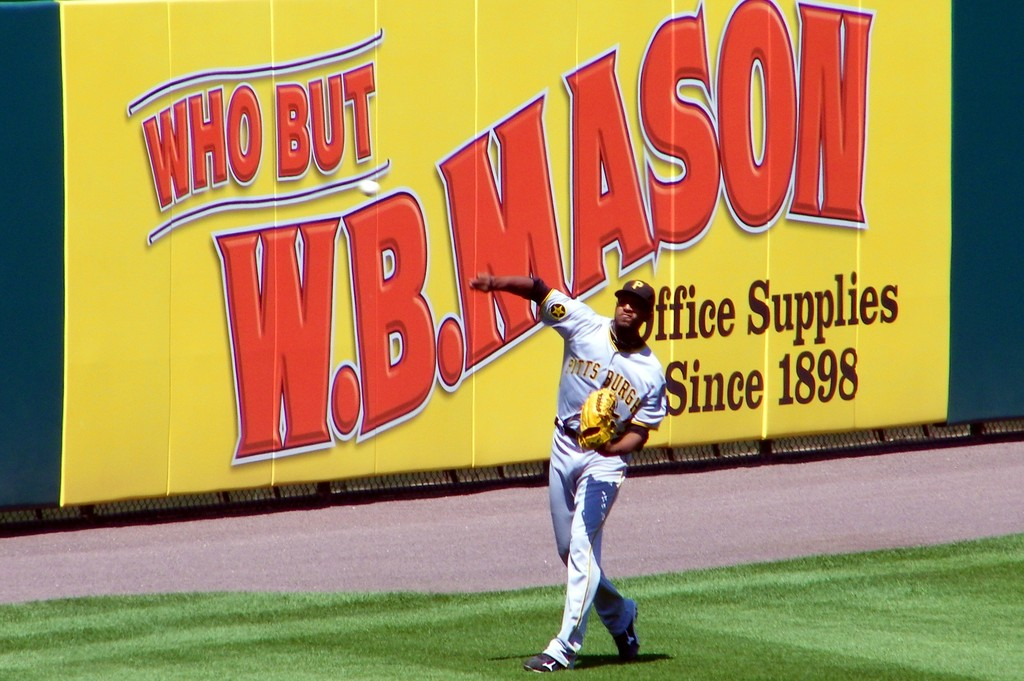Describe the action being performed by the baseball player in the image. The baseball player is captured in a dynamic pose, likely preparing to throw the ball to a teammate or towards the home plate, emphasizing his skill and focus during a game. 